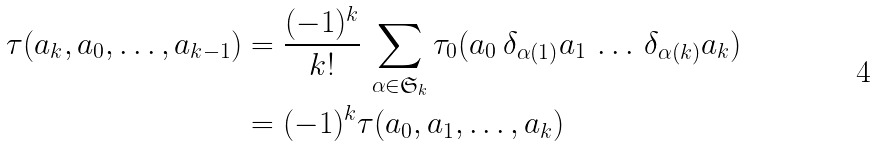Convert formula to latex. <formula><loc_0><loc_0><loc_500><loc_500>\tau ( a _ { k } , a _ { 0 } , \dots , a _ { k - 1 } ) & = \frac { ( - 1 ) ^ { k } } { k ! } \, \sum _ { \alpha \in \mathfrak { S } _ { k } } \tau _ { 0 } ( a _ { 0 } \, \delta _ { \alpha ( 1 ) } a _ { 1 } \, \dots \, \delta _ { \alpha ( k ) } a _ { k } ) \\ & = ( - 1 ) ^ { k } \tau ( a _ { 0 } , a _ { 1 } , \dots , a _ { k } )</formula> 